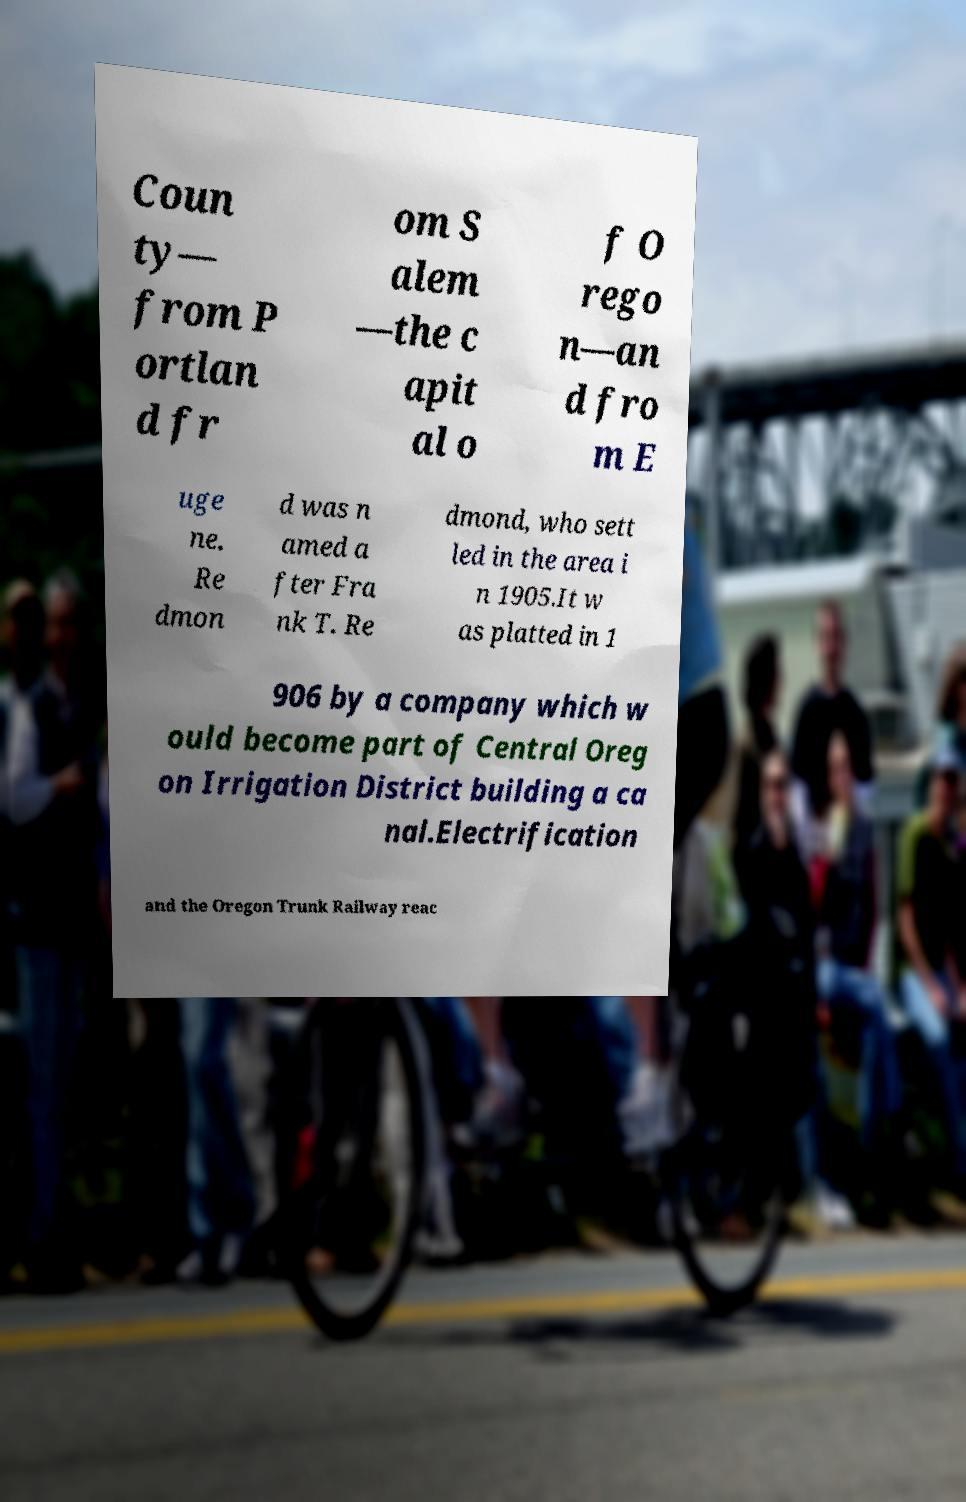For documentation purposes, I need the text within this image transcribed. Could you provide that? Coun ty— from P ortlan d fr om S alem —the c apit al o f O rego n—an d fro m E uge ne. Re dmon d was n amed a fter Fra nk T. Re dmond, who sett led in the area i n 1905.It w as platted in 1 906 by a company which w ould become part of Central Oreg on Irrigation District building a ca nal.Electrification and the Oregon Trunk Railway reac 